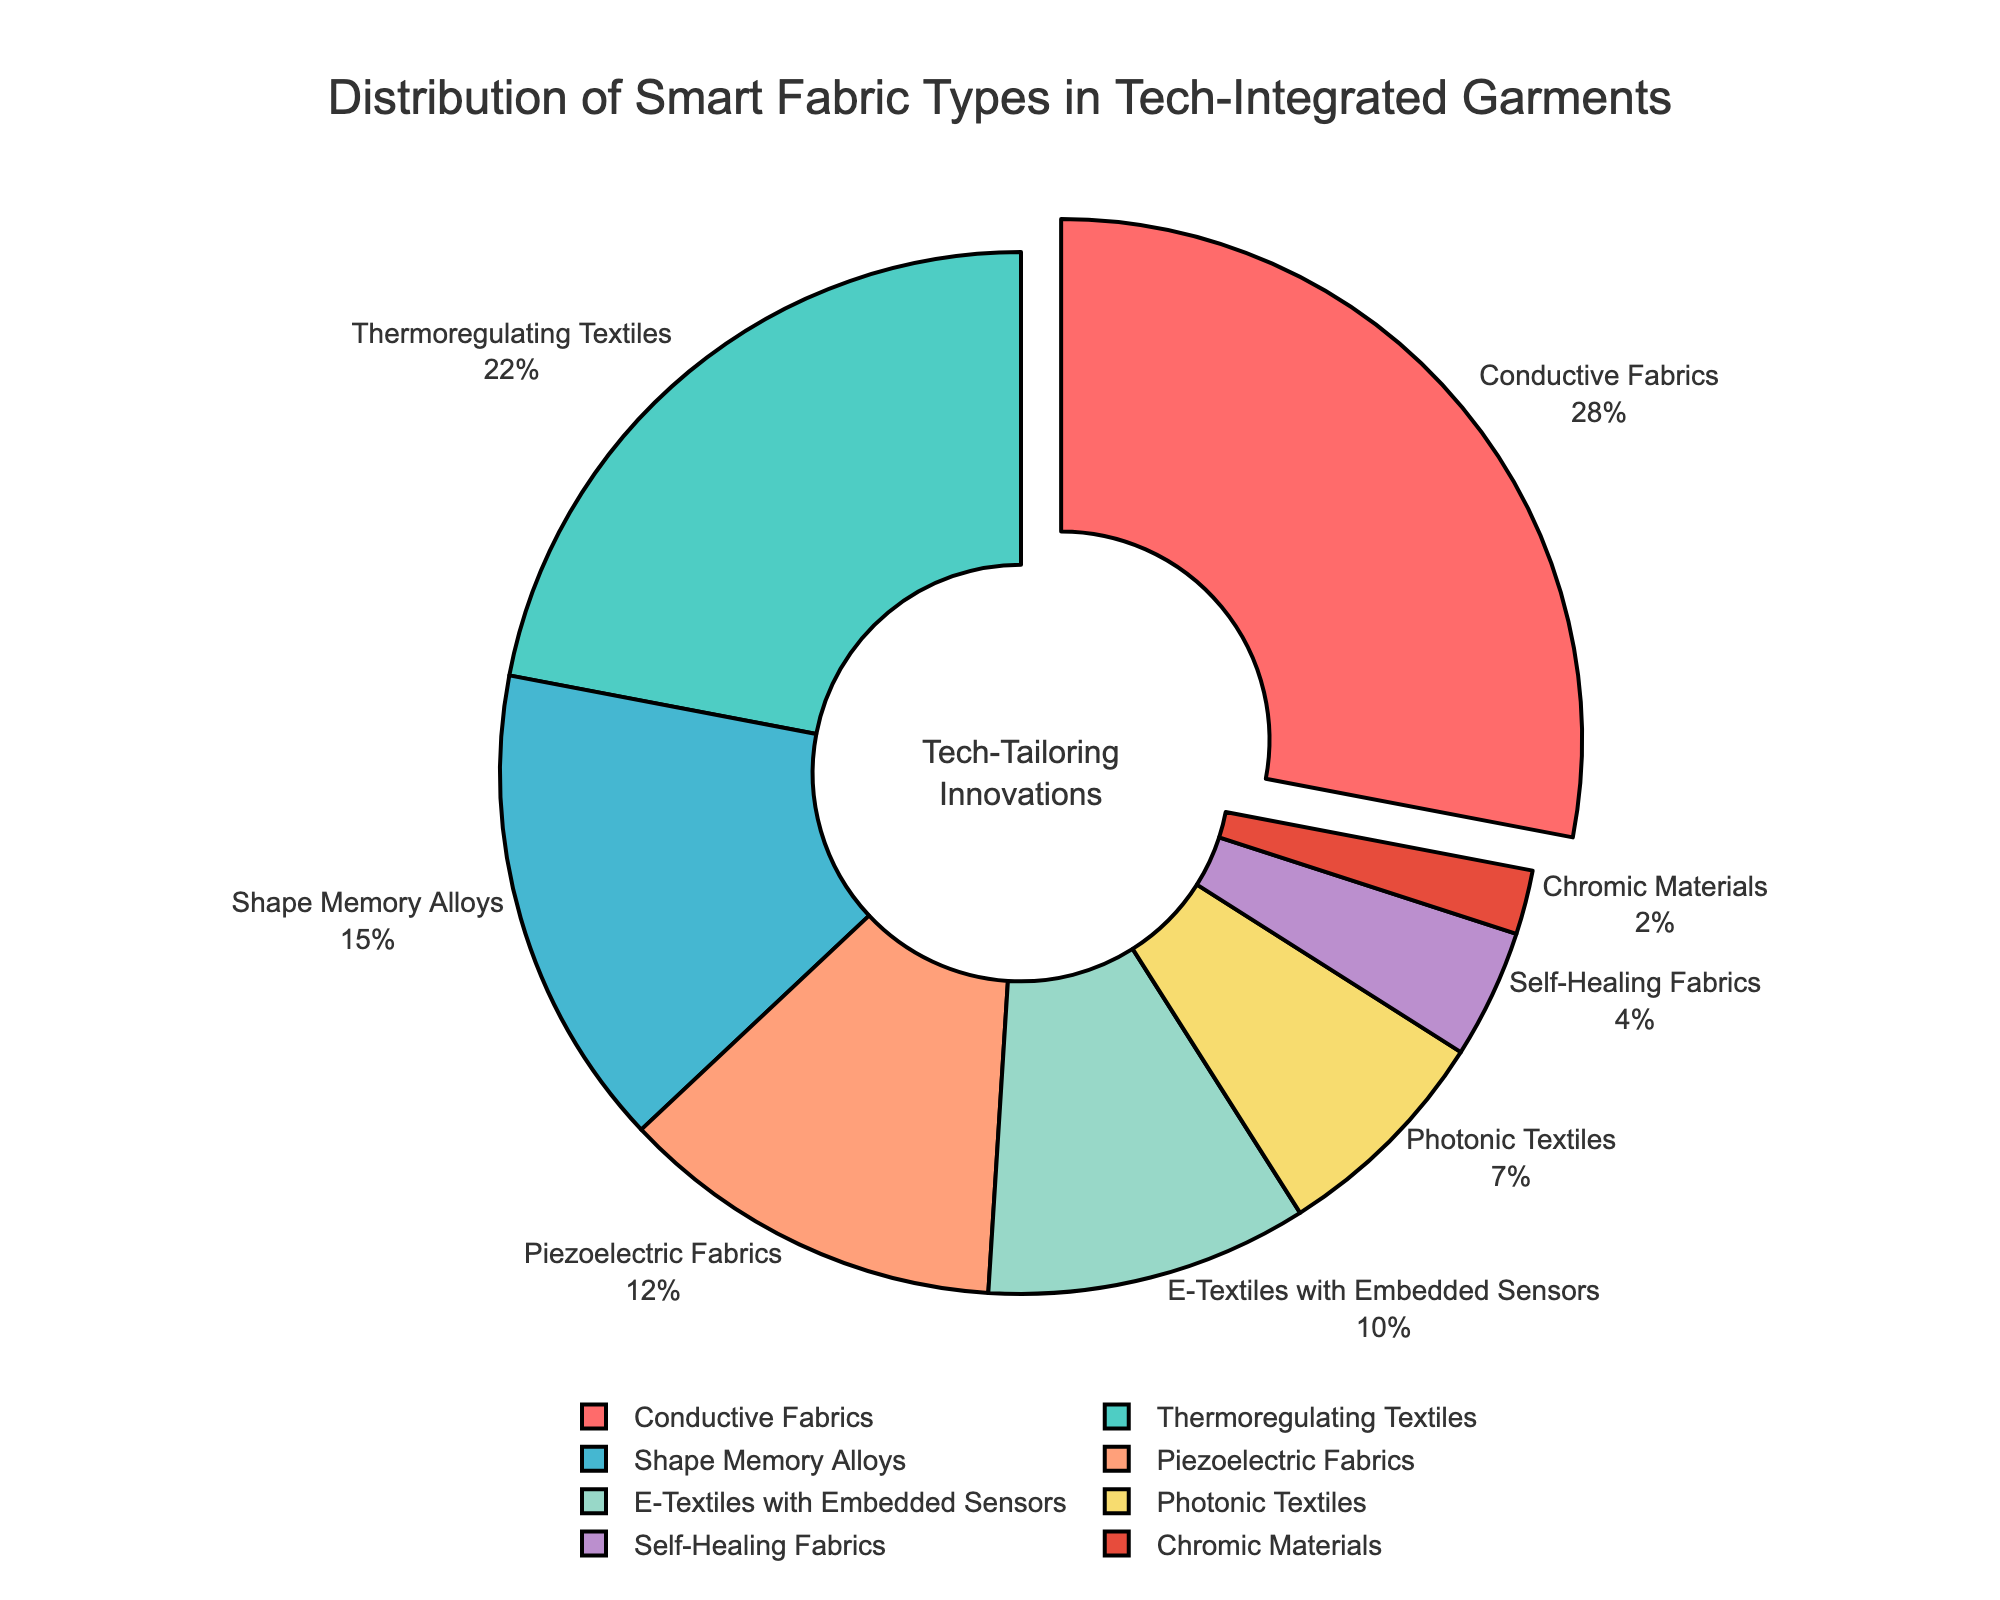Which smart fabric type constitutes the largest percentage? Look at the pie chart to identify the largest segment. Based on the size of the wedges, the largest segment is Conductive Fabrics.
Answer: Conductive Fabrics What is the combined percentage of Thermoregulating Textiles and Shape Memory Alloys? Find the percentages for Thermoregulating Textiles (22%) and Shape Memory Alloys (15%) from the pie chart and add them together: 22% + 15% = 37%.
Answer: 37% Which fabric types together form less than 10% of the total distribution? Identify slices of the pie chart that form less than 10%. E-Textiles with Embedded Sensors (10%), Photonic Textiles (7%), Self-Healing Fabrics (4%), and Chromic Materials (2%) are less than 10% by themselves. Therefore, Photonic Textiles, Self-Healing Fabrics, and Chromic Materials combined form less than 10%.
Answer: Photonic Textiles, Self-Healing Fabrics, Chromic Materials How much greater is the percentage of Conductive Fabrics compared to Piezoelectric Fabrics? Look at the percentages: Conductive Fabrics (28%) and Piezoelectric Fabrics (12%). Subtract 12% from 28%: 28% - 12% = 16%.
Answer: 16% What fabric type has the smallest representation in the chart? Identify the smallest wedge in the pie chart which represents the smallest percentage. This wedge corresponds to Chromic Materials with 2%.
Answer: Chromic Materials What is the average percentage of the three fabric types with the highest percentages? Identify the three fabric types with the highest percentages: Conductive Fabrics (28%), Thermoregulating Textiles (22%), Shape Memory Alloys (15%). Sum these and divide by 3: (28 + 22 + 15) / 3 = 65 / 3 ≈ 21.67%.
Answer: 21.67% What is the total percentage of all fabric types that contribute less than 20% each? Identify all fabric types with less than 20%: Shape Memory Alloys (15%), Piezoelectric Fabrics (12%), E-Textiles with Embedded Sensors (10%), Photonic Textiles (7%), Self-Healing Fabrics (4%), and Chromic Materials (2%). Sum these: 15% + 12% + 10% + 7% + 4% + 2% = 50%.
Answer: 50% By how much does the percentage of Thermoregulating Textiles exceed that of Photonic Textiles? Look at the percentages: Thermoregulating Textiles (22%) and Photonic Textiles (7%). Subtract 7% from 22%: 22% - 7% = 15%.
Answer: 15% What color represents Shape Memory Alloys on the chart? Look for the color corresponding to Shape Memory Alloys in the pie chart. It is represented in blue.
Answer: Blue 